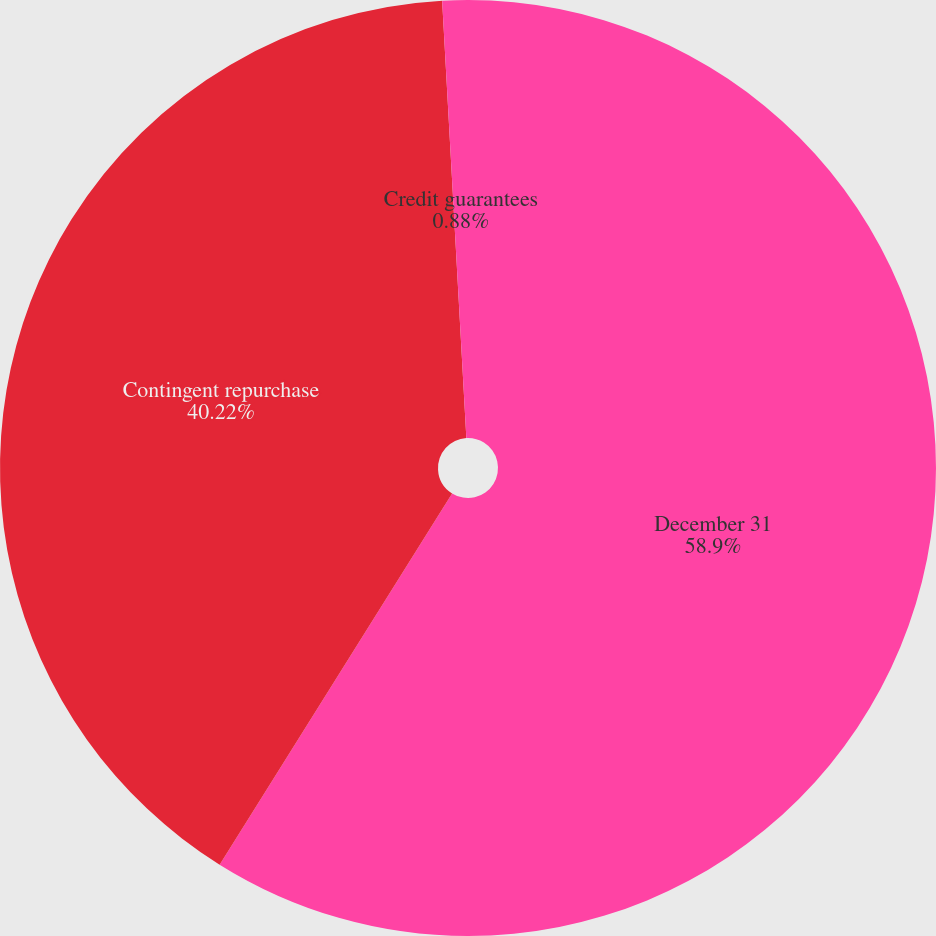Convert chart to OTSL. <chart><loc_0><loc_0><loc_500><loc_500><pie_chart><fcel>December 31<fcel>Contingent repurchase<fcel>Credit guarantees<nl><fcel>58.91%<fcel>40.22%<fcel>0.88%<nl></chart> 